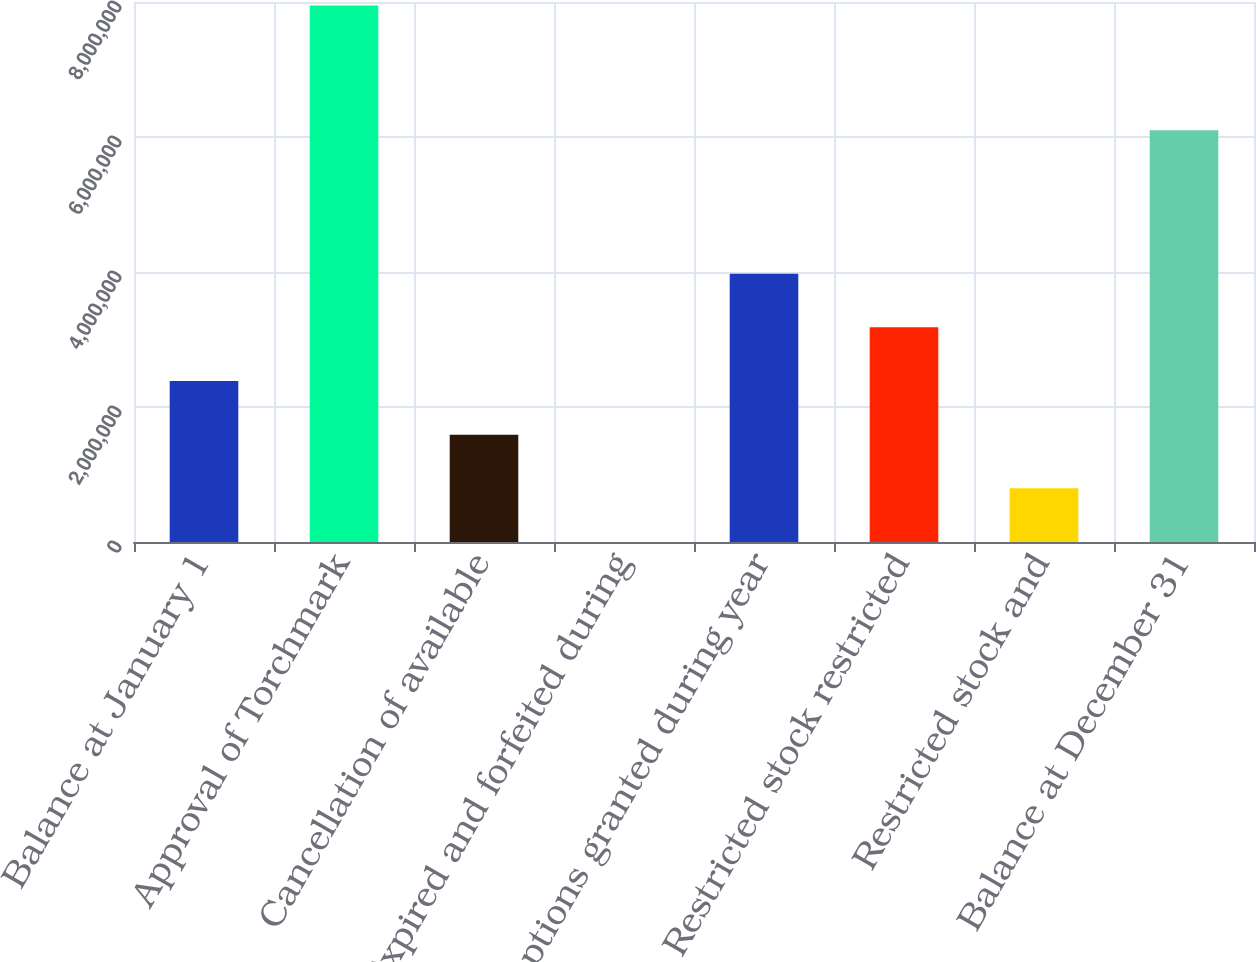Convert chart. <chart><loc_0><loc_0><loc_500><loc_500><bar_chart><fcel>Balance at January 1<fcel>Approval of Torchmark<fcel>Cancellation of available<fcel>Expired and forfeited during<fcel>Options granted during year<fcel>Restricted stock restricted<fcel>Restricted stock and<fcel>Balance at December 31<nl><fcel>2.385e+06<fcel>7.95e+06<fcel>1.59e+06<fcel>4.17<fcel>3.975e+06<fcel>3.18e+06<fcel>795004<fcel>6.09934e+06<nl></chart> 